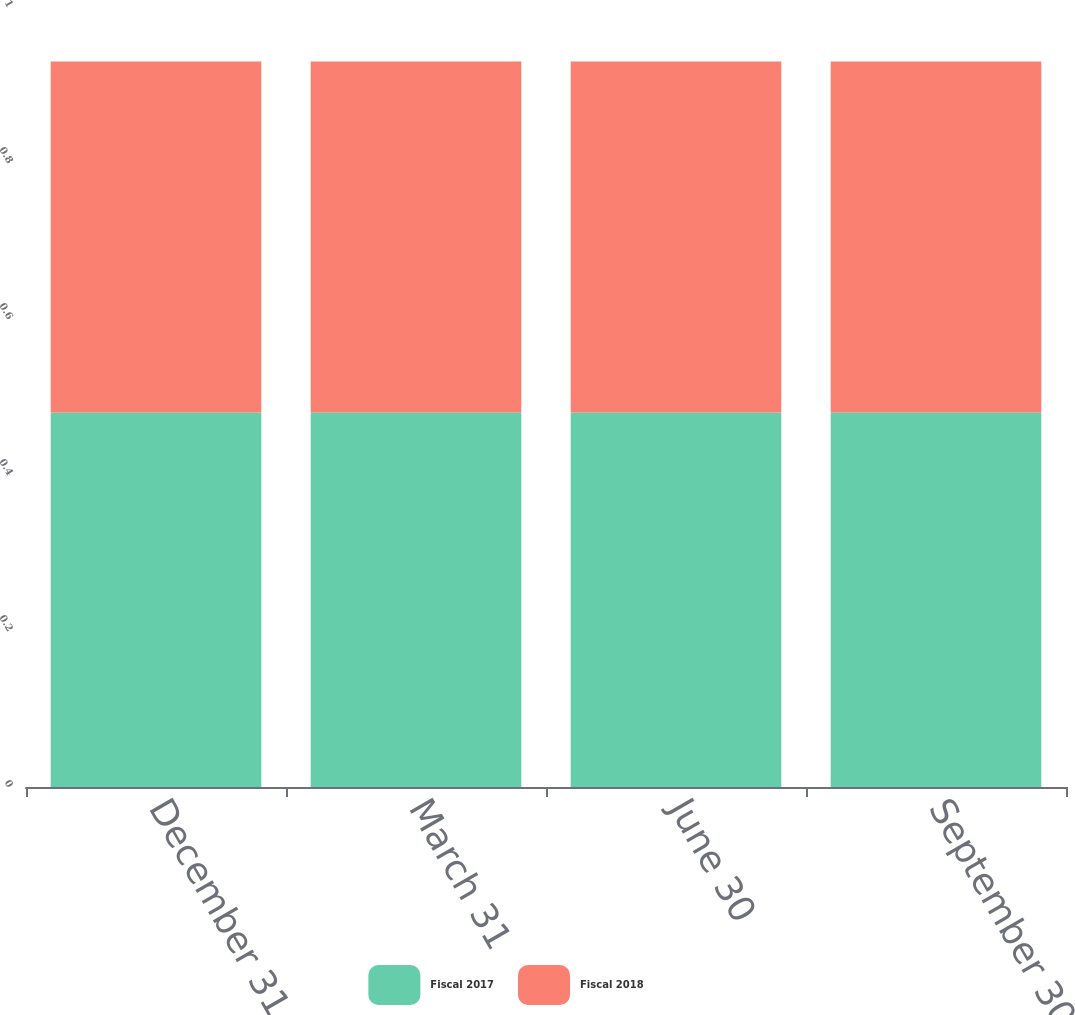Convert chart. <chart><loc_0><loc_0><loc_500><loc_500><stacked_bar_chart><ecel><fcel>December 31<fcel>March 31<fcel>June 30<fcel>September 30<nl><fcel>Fiscal 2017<fcel>0.48<fcel>0.48<fcel>0.48<fcel>0.48<nl><fcel>Fiscal 2018<fcel>0.45<fcel>0.45<fcel>0.45<fcel>0.45<nl></chart> 